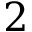<formula> <loc_0><loc_0><loc_500><loc_500>2</formula> 